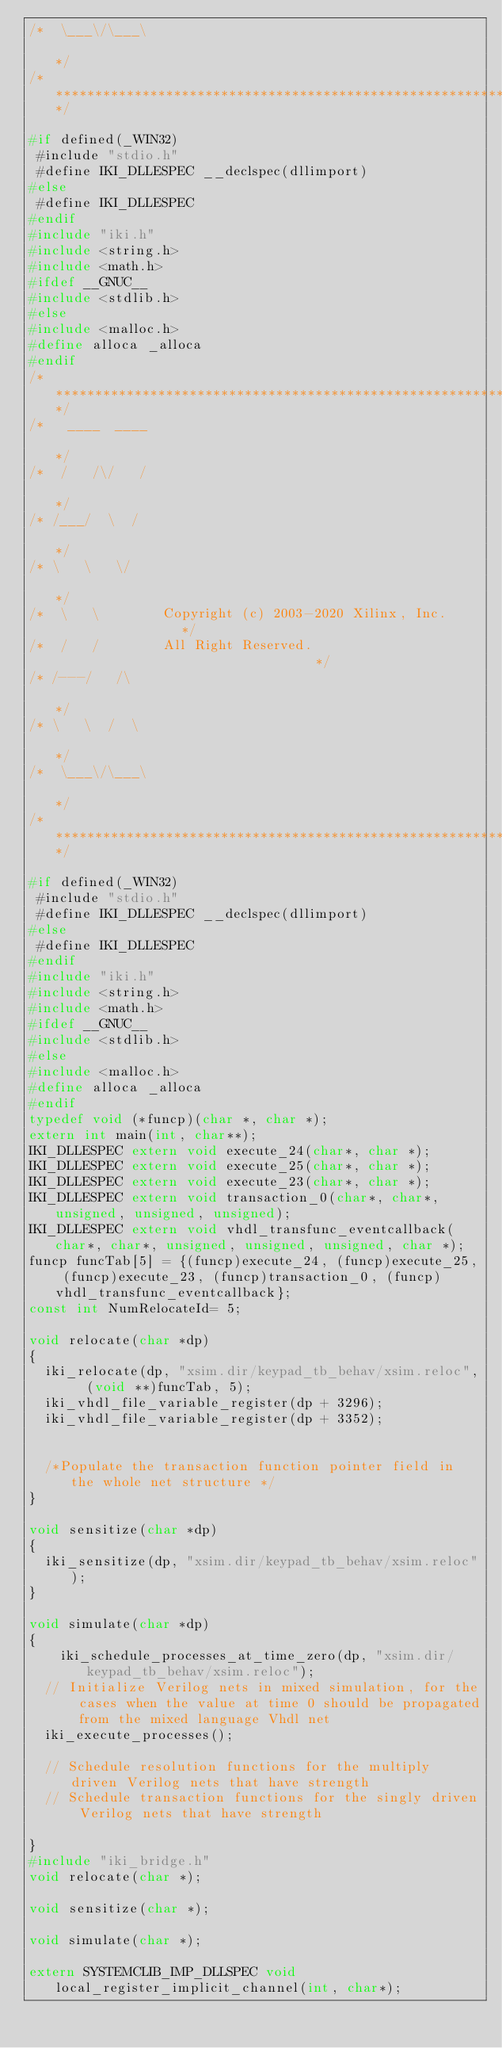Convert code to text. <code><loc_0><loc_0><loc_500><loc_500><_C_>/*  \___\/\___\                                                       */
/**********************************************************************/

#if defined(_WIN32)
 #include "stdio.h"
 #define IKI_DLLESPEC __declspec(dllimport)
#else
 #define IKI_DLLESPEC
#endif
#include "iki.h"
#include <string.h>
#include <math.h>
#ifdef __GNUC__
#include <stdlib.h>
#else
#include <malloc.h>
#define alloca _alloca
#endif
/**********************************************************************/
/*   ____  ____                                                       */
/*  /   /\/   /                                                       */
/* /___/  \  /                                                        */
/* \   \   \/                                                         */
/*  \   \        Copyright (c) 2003-2020 Xilinx, Inc.                 */
/*  /   /        All Right Reserved.                                  */
/* /---/   /\                                                         */
/* \   \  /  \                                                        */
/*  \___\/\___\                                                       */
/**********************************************************************/

#if defined(_WIN32)
 #include "stdio.h"
 #define IKI_DLLESPEC __declspec(dllimport)
#else
 #define IKI_DLLESPEC
#endif
#include "iki.h"
#include <string.h>
#include <math.h>
#ifdef __GNUC__
#include <stdlib.h>
#else
#include <malloc.h>
#define alloca _alloca
#endif
typedef void (*funcp)(char *, char *);
extern int main(int, char**);
IKI_DLLESPEC extern void execute_24(char*, char *);
IKI_DLLESPEC extern void execute_25(char*, char *);
IKI_DLLESPEC extern void execute_23(char*, char *);
IKI_DLLESPEC extern void transaction_0(char*, char*, unsigned, unsigned, unsigned);
IKI_DLLESPEC extern void vhdl_transfunc_eventcallback(char*, char*, unsigned, unsigned, unsigned, char *);
funcp funcTab[5] = {(funcp)execute_24, (funcp)execute_25, (funcp)execute_23, (funcp)transaction_0, (funcp)vhdl_transfunc_eventcallback};
const int NumRelocateId= 5;

void relocate(char *dp)
{
	iki_relocate(dp, "xsim.dir/keypad_tb_behav/xsim.reloc",  (void **)funcTab, 5);
	iki_vhdl_file_variable_register(dp + 3296);
	iki_vhdl_file_variable_register(dp + 3352);


	/*Populate the transaction function pointer field in the whole net structure */
}

void sensitize(char *dp)
{
	iki_sensitize(dp, "xsim.dir/keypad_tb_behav/xsim.reloc");
}

void simulate(char *dp)
{
		iki_schedule_processes_at_time_zero(dp, "xsim.dir/keypad_tb_behav/xsim.reloc");
	// Initialize Verilog nets in mixed simulation, for the cases when the value at time 0 should be propagated from the mixed language Vhdl net
	iki_execute_processes();

	// Schedule resolution functions for the multiply driven Verilog nets that have strength
	// Schedule transaction functions for the singly driven Verilog nets that have strength

}
#include "iki_bridge.h"
void relocate(char *);

void sensitize(char *);

void simulate(char *);

extern SYSTEMCLIB_IMP_DLLSPEC void local_register_implicit_channel(int, char*);</code> 